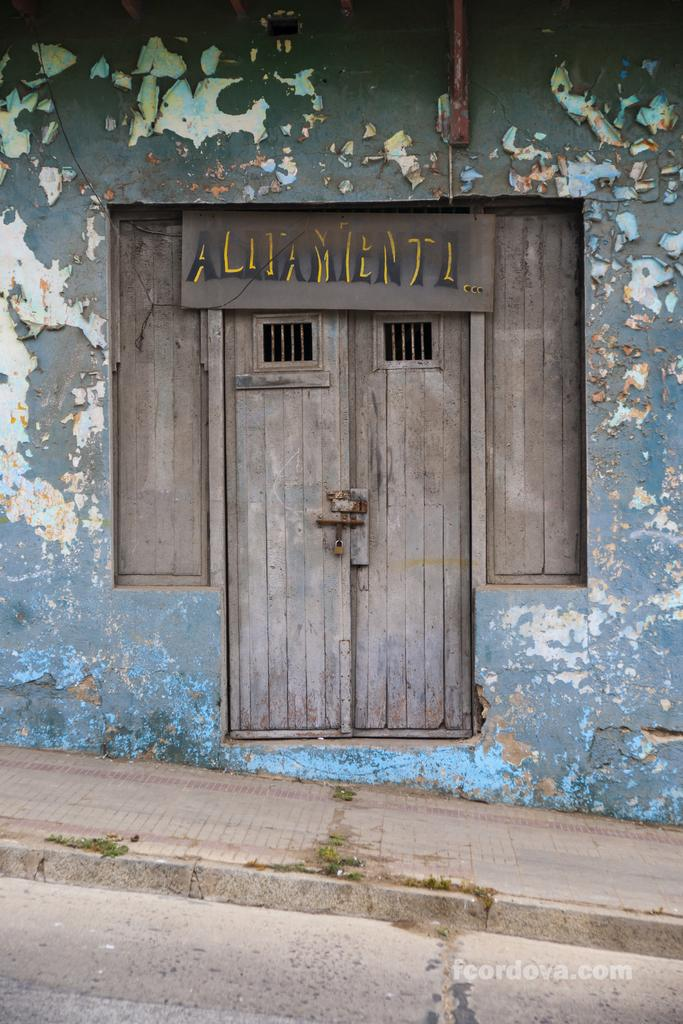What type of structure is visible in the image? There is a door, windows, and a wall visible in the image. What type of pathway is present in the image? There is a footpath in the image. What type of transportation route is present in the image? There is a road in the image. Can you see a cap floating down the stream in the image? There is no cap or stream present in the image. What type of snack is being served in the image? There is no snack, such as popcorn, present in the image. 